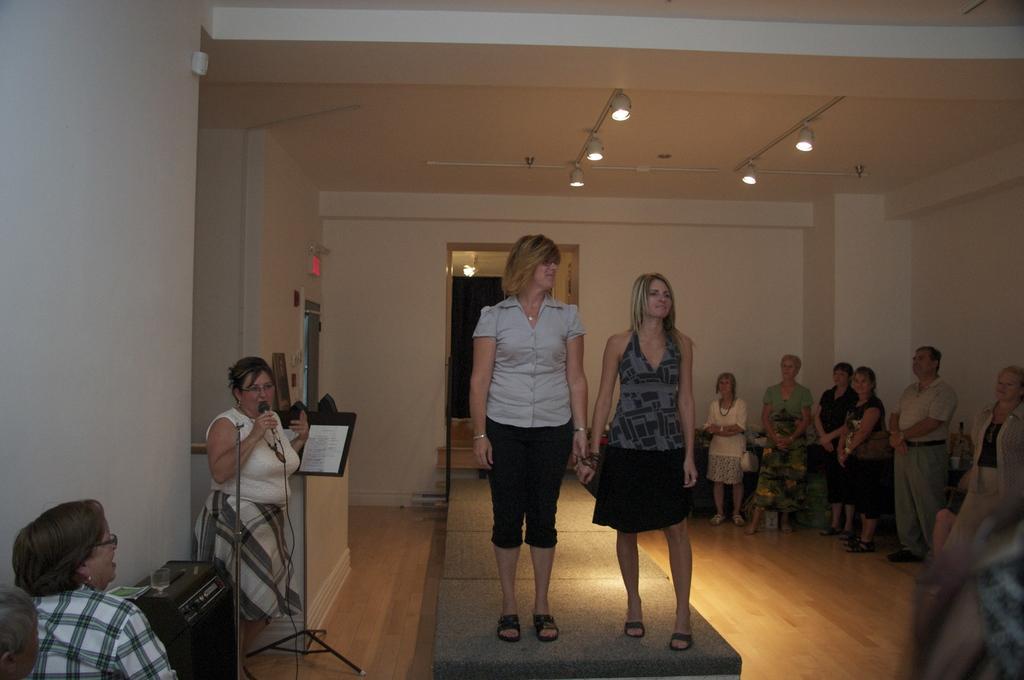Can you describe this image briefly? In this picture there are people, among them there is a woman standing and holding a microphone. We can see paper on stand, glass on device and floor. In the background of the image we can see wall, board and lights. 